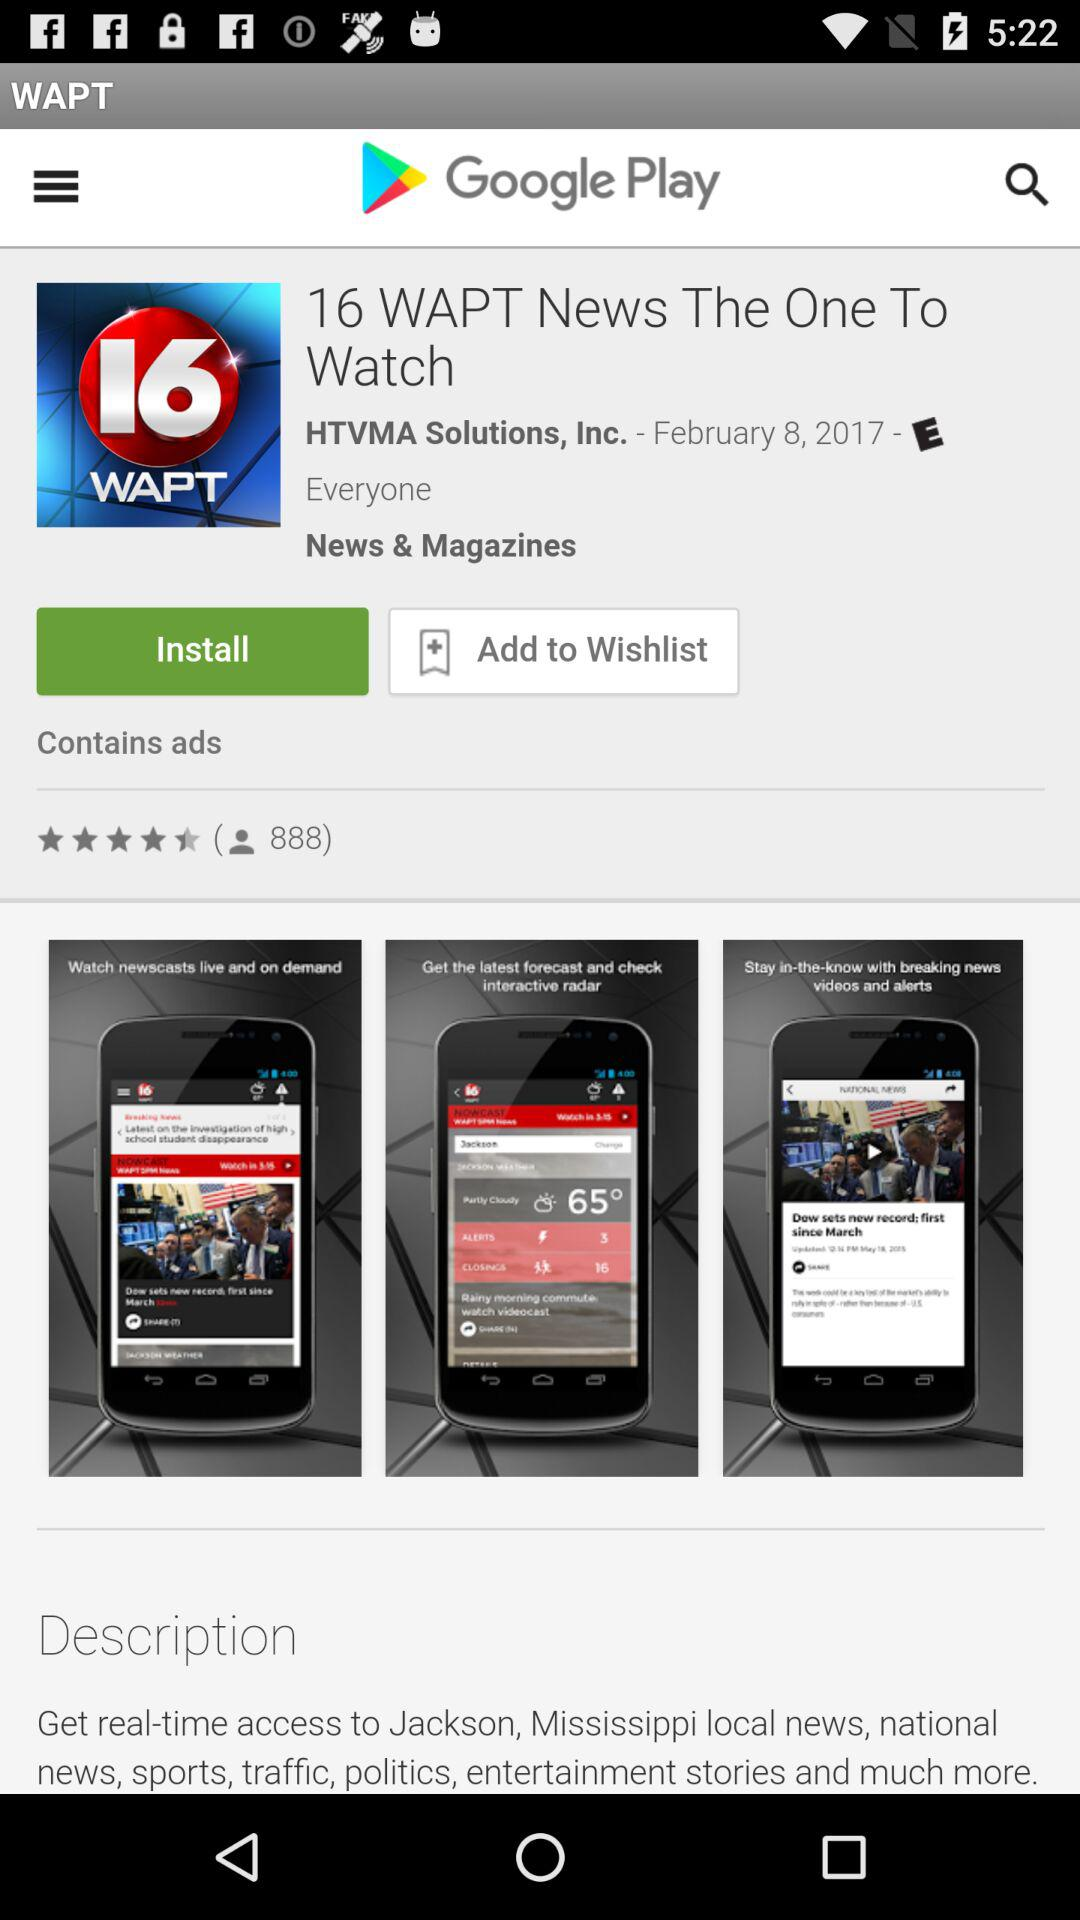What's the launch date of the application? The launch date of the application is February 8, 2017. 